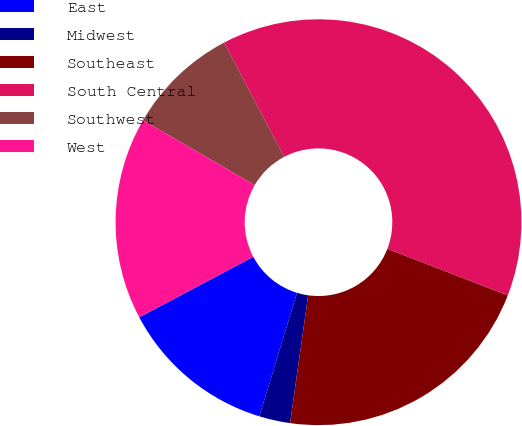Convert chart. <chart><loc_0><loc_0><loc_500><loc_500><pie_chart><fcel>East<fcel>Midwest<fcel>Southeast<fcel>South Central<fcel>Southwest<fcel>West<nl><fcel>12.53%<fcel>2.47%<fcel>21.37%<fcel>38.57%<fcel>8.92%<fcel>16.14%<nl></chart> 